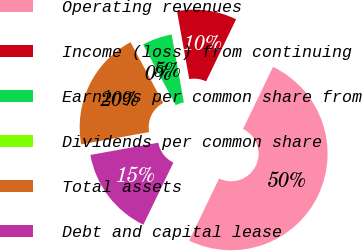<chart> <loc_0><loc_0><loc_500><loc_500><pie_chart><fcel>Operating revenues<fcel>Income (loss) from continuing<fcel>Earnings per common share from<fcel>Dividends per common share<fcel>Total assets<fcel>Debt and capital lease<nl><fcel>50.0%<fcel>10.0%<fcel>5.0%<fcel>0.0%<fcel>20.0%<fcel>15.0%<nl></chart> 